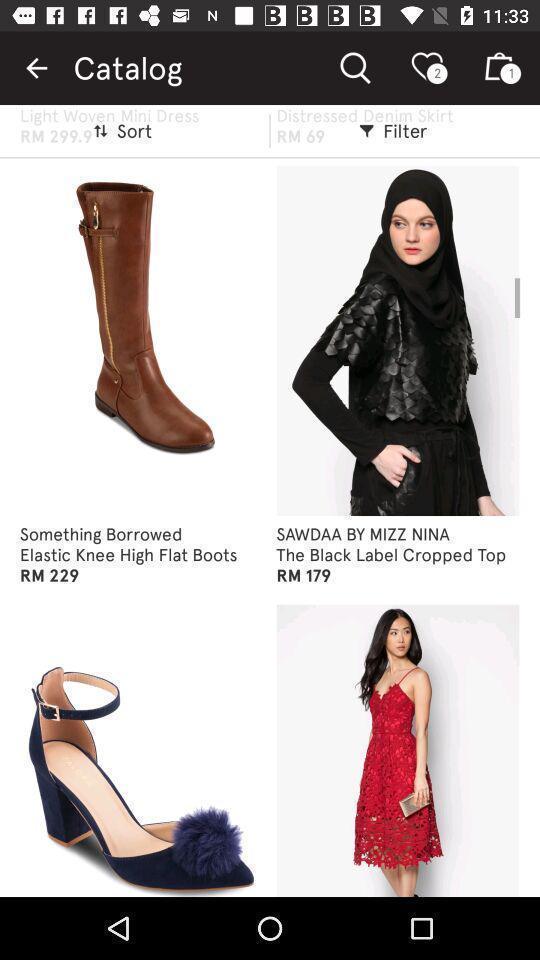Describe the content in this image. Shopping app displayed catalog of different items. 